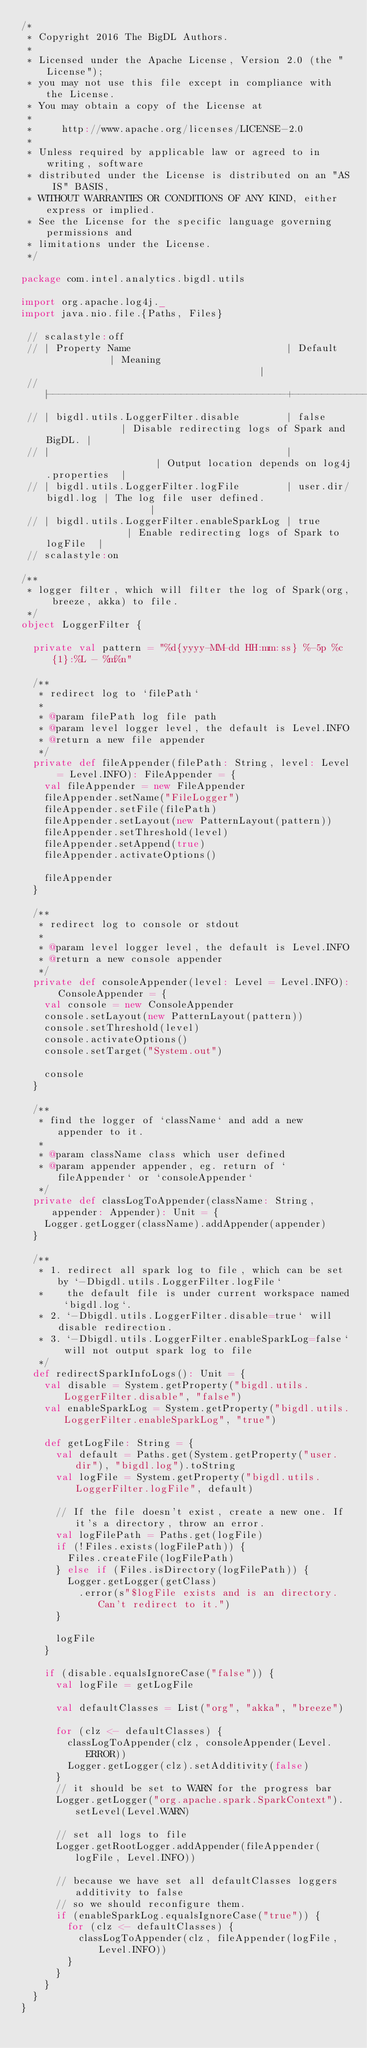Convert code to text. <code><loc_0><loc_0><loc_500><loc_500><_Scala_>/*
 * Copyright 2016 The BigDL Authors.
 *
 * Licensed under the Apache License, Version 2.0 (the "License");
 * you may not use this file except in compliance with the License.
 * You may obtain a copy of the License at
 *
 *     http://www.apache.org/licenses/LICENSE-2.0
 *
 * Unless required by applicable law or agreed to in writing, software
 * distributed under the License is distributed on an "AS IS" BASIS,
 * WITHOUT WARRANTIES OR CONDITIONS OF ANY KIND, either express or implied.
 * See the License for the specific language governing permissions and
 * limitations under the License.
 */

package com.intel.analytics.bigdl.utils

import org.apache.log4j._
import java.nio.file.{Paths, Files}

 // scalastyle:off
 // | Property Name                           | Default            | Meaning                                      |
 // |-----------------------------------------+--------------------+----------------------------------------------|
 // | bigdl.utils.LoggerFilter.disable        | false              | Disable redirecting logs of Spark and BigDL. |
 // |                                         |                    | Output location depends on log4j.properties  |
 // | bigdl.utils.LoggerFilter.logFile        | user.dir/bigdl.log | The log file user defined.                   |
 // | bigdl.utils.LoggerFilter.enableSparkLog | true               | Enable redirecting logs of Spark to logFile  |
 // scalastyle:on

/**
 * logger filter, which will filter the log of Spark(org, breeze, akka) to file.
 */
object LoggerFilter {

  private val pattern = "%d{yyyy-MM-dd HH:mm:ss} %-5p %c{1}:%L - %m%n"

  /**
   * redirect log to `filePath`
   *
   * @param filePath log file path
   * @param level logger level, the default is Level.INFO
   * @return a new file appender
   */
  private def fileAppender(filePath: String, level: Level = Level.INFO): FileAppender = {
    val fileAppender = new FileAppender
    fileAppender.setName("FileLogger")
    fileAppender.setFile(filePath)
    fileAppender.setLayout(new PatternLayout(pattern))
    fileAppender.setThreshold(level)
    fileAppender.setAppend(true)
    fileAppender.activateOptions()

    fileAppender
  }

  /**
   * redirect log to console or stdout
   *
   * @param level logger level, the default is Level.INFO
   * @return a new console appender
   */
  private def consoleAppender(level: Level = Level.INFO): ConsoleAppender = {
    val console = new ConsoleAppender
    console.setLayout(new PatternLayout(pattern))
    console.setThreshold(level)
    console.activateOptions()
    console.setTarget("System.out")

    console
  }

  /**
   * find the logger of `className` and add a new appender to it.
   *
   * @param className class which user defined
   * @param appender appender, eg. return of `fileAppender` or `consoleAppender`
   */
  private def classLogToAppender(className: String, appender: Appender): Unit = {
    Logger.getLogger(className).addAppender(appender)
  }

  /**
   * 1. redirect all spark log to file, which can be set by `-Dbigdl.utils.LoggerFilter.logFile`
   *    the default file is under current workspace named `bigdl.log`.
   * 2. `-Dbigdl.utils.LoggerFilter.disable=true` will disable redirection.
   * 3. `-Dbigdl.utils.LoggerFilter.enableSparkLog=false` will not output spark log to file
   */
  def redirectSparkInfoLogs(): Unit = {
    val disable = System.getProperty("bigdl.utils.LoggerFilter.disable", "false")
    val enableSparkLog = System.getProperty("bigdl.utils.LoggerFilter.enableSparkLog", "true")

    def getLogFile: String = {
      val default = Paths.get(System.getProperty("user.dir"), "bigdl.log").toString
      val logFile = System.getProperty("bigdl.utils.LoggerFilter.logFile", default)

      // If the file doesn't exist, create a new one. If it's a directory, throw an error.
      val logFilePath = Paths.get(logFile)
      if (!Files.exists(logFilePath)) {
        Files.createFile(logFilePath)
      } else if (Files.isDirectory(logFilePath)) {
        Logger.getLogger(getClass)
          .error(s"$logFile exists and is an directory. Can't redirect to it.")
      }

      logFile
    }

    if (disable.equalsIgnoreCase("false")) {
      val logFile = getLogFile

      val defaultClasses = List("org", "akka", "breeze")

      for (clz <- defaultClasses) {
        classLogToAppender(clz, consoleAppender(Level.ERROR))
        Logger.getLogger(clz).setAdditivity(false)
      }
      // it should be set to WARN for the progress bar
      Logger.getLogger("org.apache.spark.SparkContext").setLevel(Level.WARN)

      // set all logs to file
      Logger.getRootLogger.addAppender(fileAppender(logFile, Level.INFO))

      // because we have set all defaultClasses loggers additivity to false
      // so we should reconfigure them.
      if (enableSparkLog.equalsIgnoreCase("true")) {
        for (clz <- defaultClasses) {
          classLogToAppender(clz, fileAppender(logFile, Level.INFO))
        }
      }
    }
  }
}
</code> 